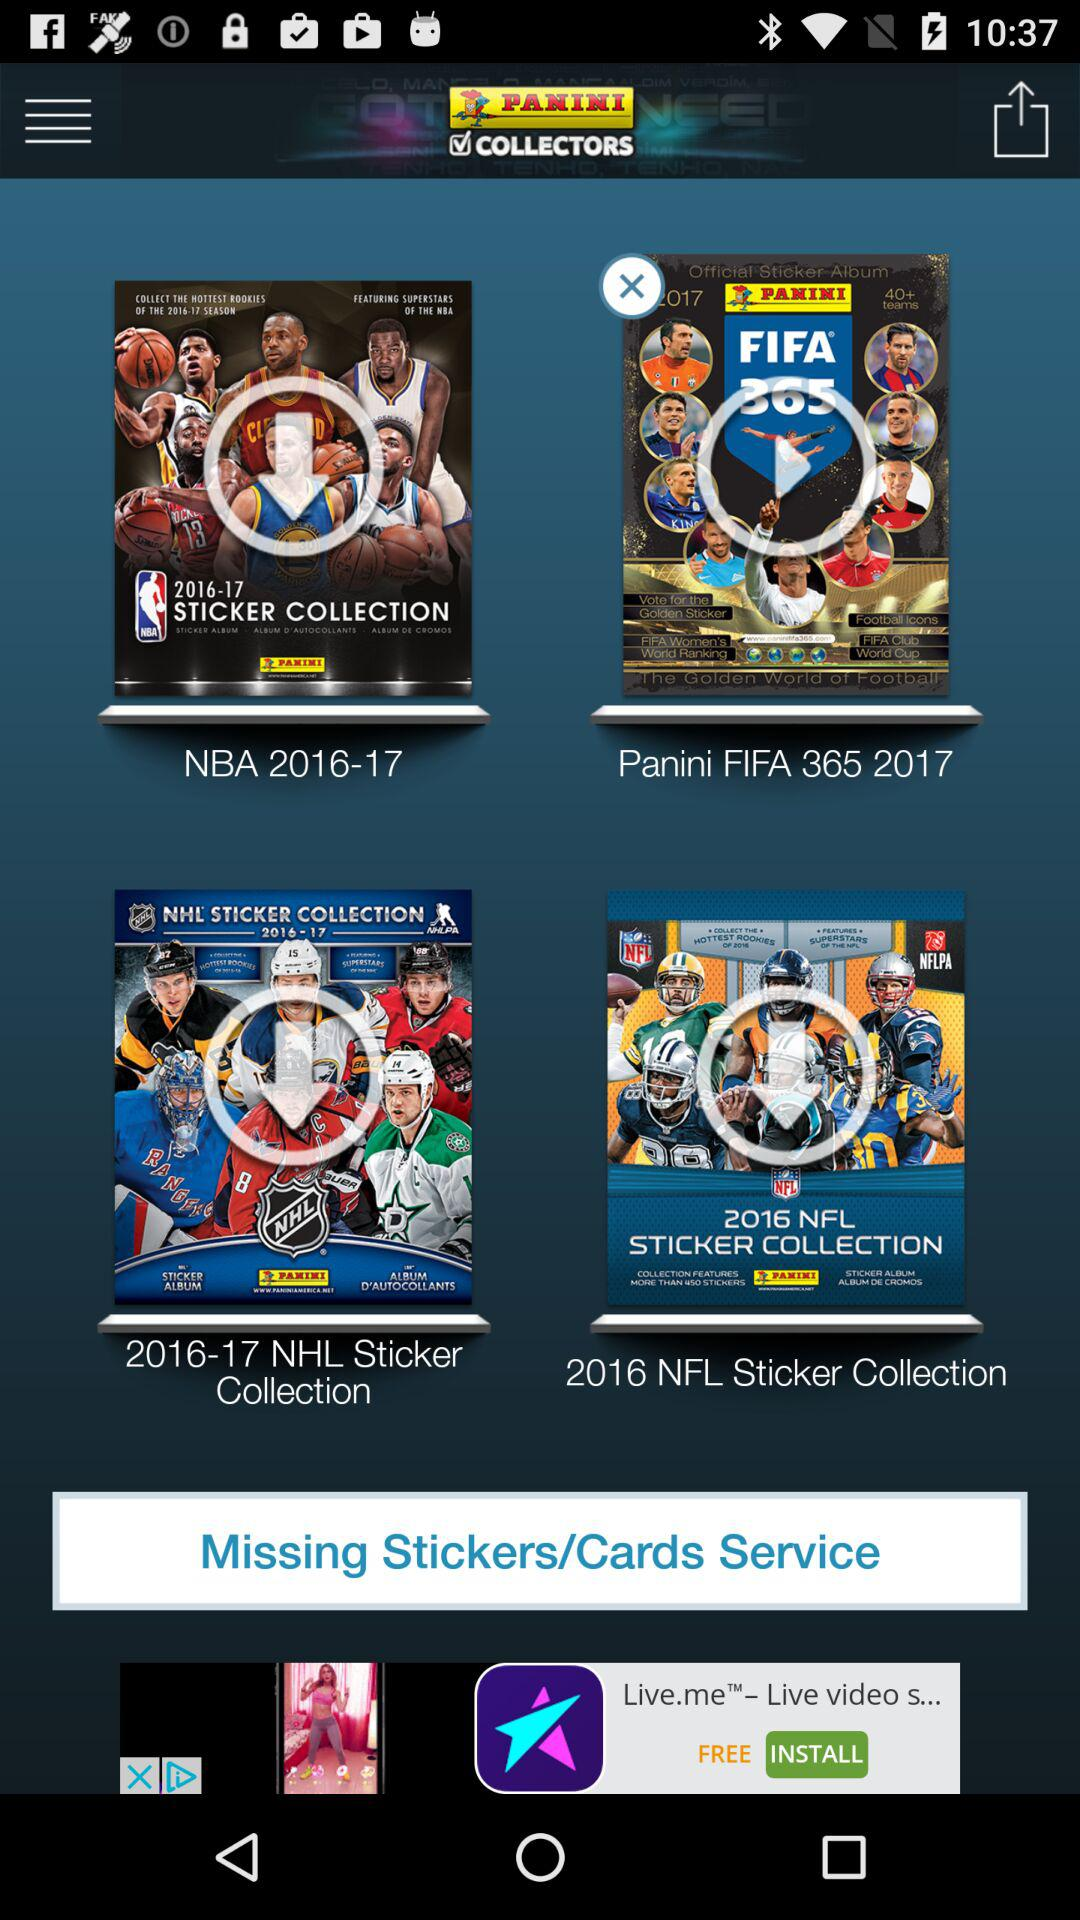How many sticker collections are there?
Answer the question using a single word or phrase. 4 